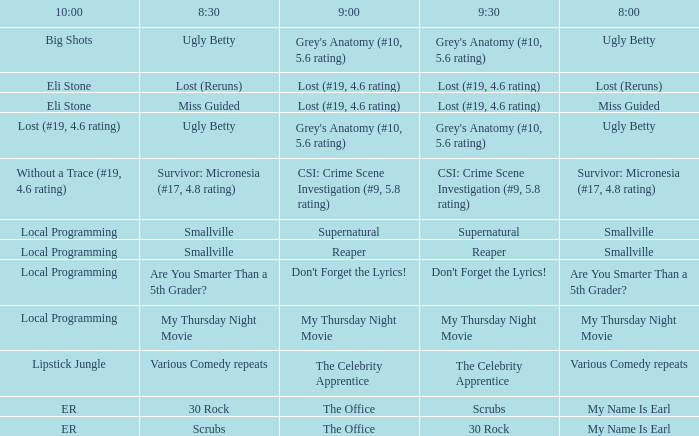What is at 8:00 when at 8:30 it is my thursday night movie? My Thursday Night Movie. 